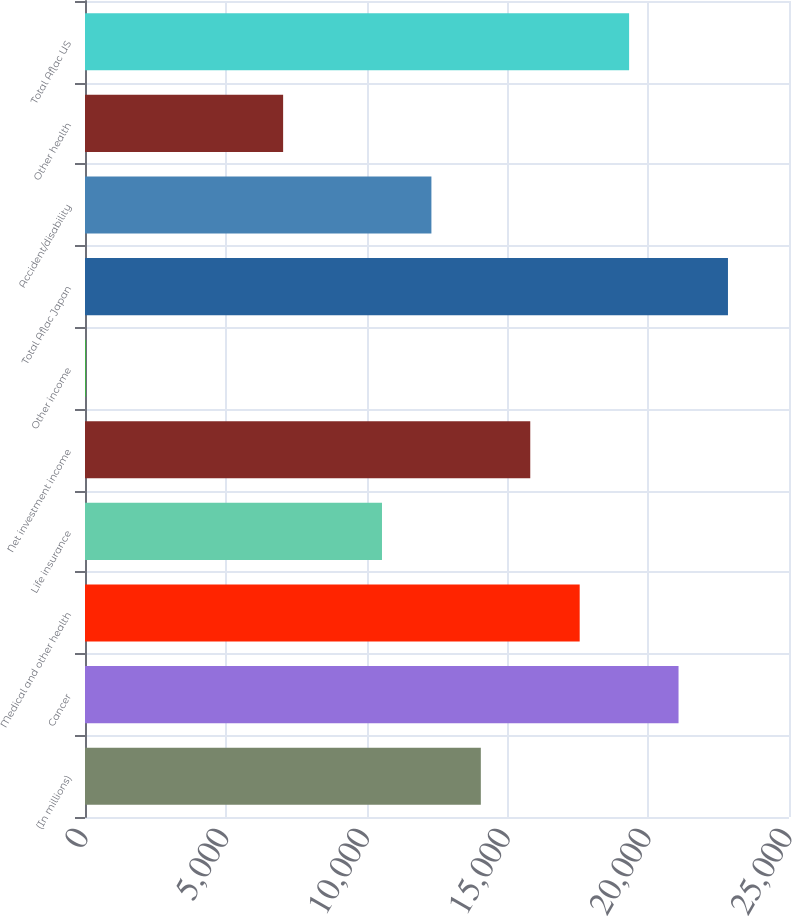Convert chart. <chart><loc_0><loc_0><loc_500><loc_500><bar_chart><fcel>(In millions)<fcel>Cancer<fcel>Medical and other health<fcel>Life insurance<fcel>Net investment income<fcel>Other income<fcel>Total Aflac Japan<fcel>Accident/disability<fcel>Other health<fcel>Total Aflac US<nl><fcel>14056.6<fcel>21077.4<fcel>17567<fcel>10546.2<fcel>15811.8<fcel>15<fcel>22832.6<fcel>12301.4<fcel>7035.8<fcel>19322.2<nl></chart> 